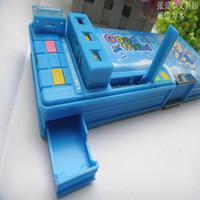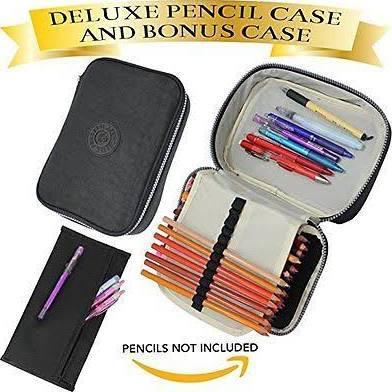The first image is the image on the left, the second image is the image on the right. For the images displayed, is the sentence "There is a predominantly pink pencel case on top of a white table in one of the images." factually correct? Answer yes or no. No. The first image is the image on the left, the second image is the image on the right. Considering the images on both sides, is "One image features a single pastel-colored plastic-look case with a side part that can extend outward." valid? Answer yes or no. Yes. 